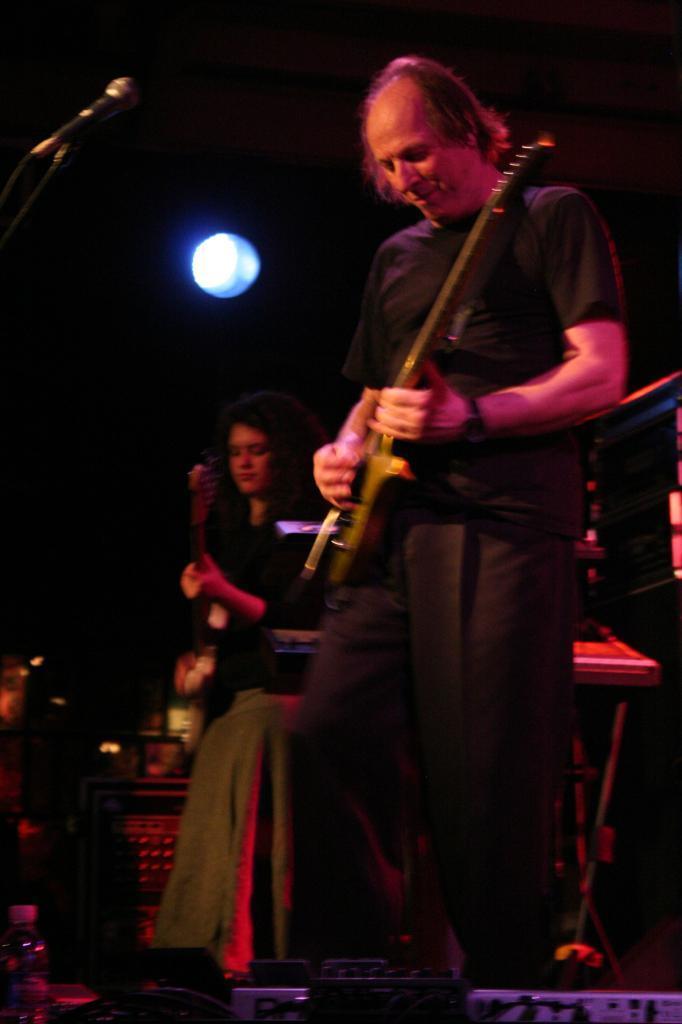In one or two sentences, can you explain what this image depicts? This image is taken in an open air concert stage where two persons are standing and playing guitar in front of the mike. In the left bottom, a person is sitting on the chair. Beside that there is a table. On the top, a light is visible. 